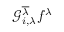Convert formula to latex. <formula><loc_0><loc_0><loc_500><loc_500>\mathcal { G } _ { i , \lambda } ^ { \overline { \lambda } } f ^ { \lambda }</formula> 